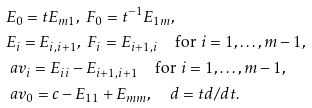Convert formula to latex. <formula><loc_0><loc_0><loc_500><loc_500>& E _ { 0 } = t E _ { m 1 } , \ F _ { 0 } = t ^ { - 1 } E _ { 1 m } , \\ & E _ { i } = E _ { i , i + 1 } , \ F _ { i } = E _ { i + 1 , i } \quad \text {for $i=1,\dots,m-1$} , \\ & \ a v _ { i } = E _ { i i } - E _ { i + 1 , i + 1 } \quad \text {for $i=1,\dots,m-1$} , \\ & \ a v _ { 0 } = c - E _ { 1 1 } + E _ { m m } , \quad d = t d / d t .</formula> 